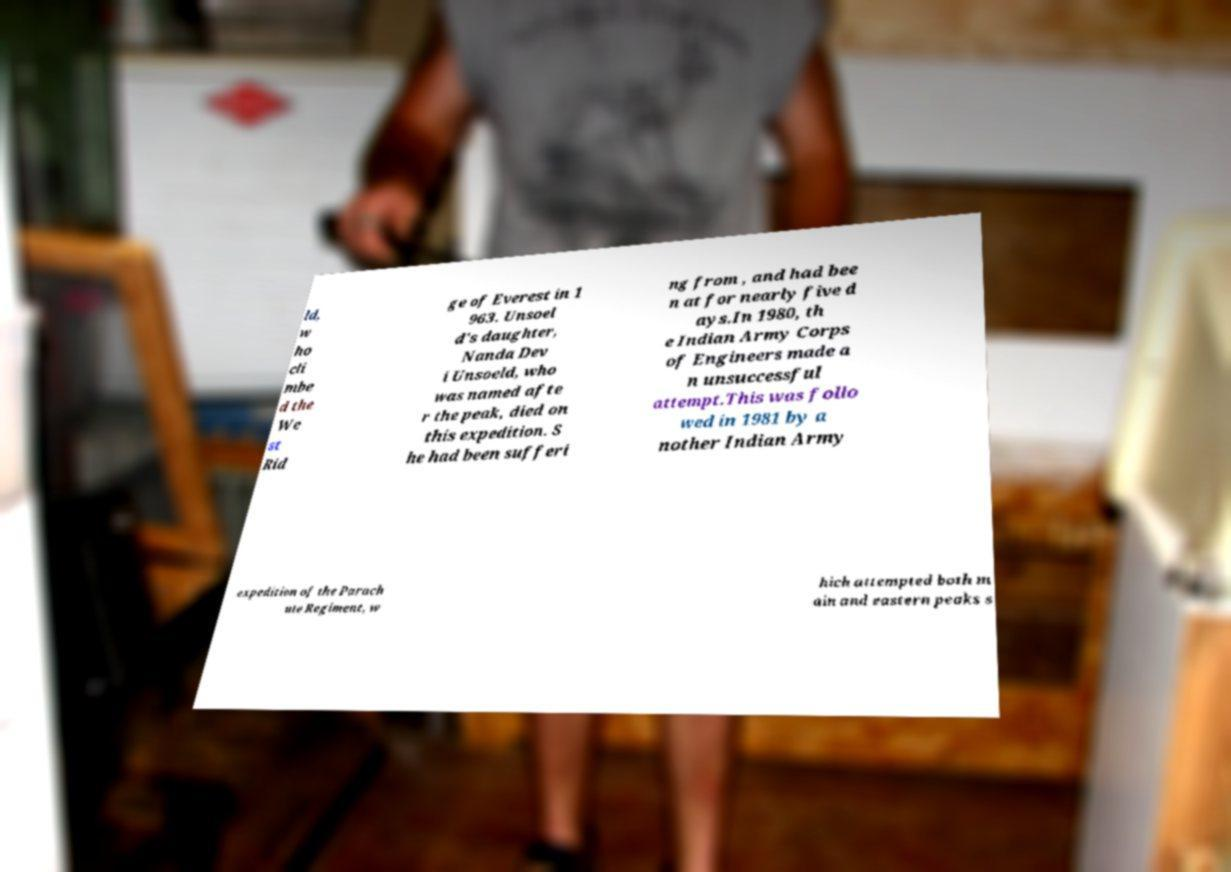Please identify and transcribe the text found in this image. ld, w ho cli mbe d the We st Rid ge of Everest in 1 963. Unsoel d's daughter, Nanda Dev i Unsoeld, who was named afte r the peak, died on this expedition. S he had been sufferi ng from , and had bee n at for nearly five d ays.In 1980, th e Indian Army Corps of Engineers made a n unsuccessful attempt.This was follo wed in 1981 by a nother Indian Army expedition of the Parach ute Regiment, w hich attempted both m ain and eastern peaks s 